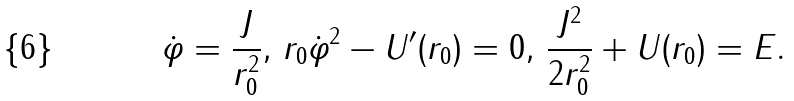<formula> <loc_0><loc_0><loc_500><loc_500>\dot { \varphi } = \frac { J } { r _ { 0 } ^ { 2 } } , \, r _ { 0 } \dot { \varphi } ^ { 2 } - U ^ { \prime } ( r _ { 0 } ) = 0 , \, \frac { J ^ { 2 } } { 2 r _ { 0 } ^ { 2 } } + U ( r _ { 0 } ) = E .</formula> 